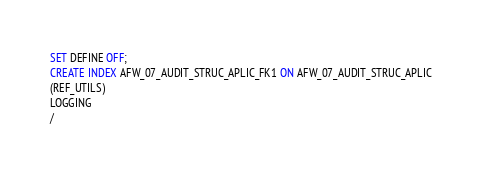Convert code to text. <code><loc_0><loc_0><loc_500><loc_500><_SQL_>SET DEFINE OFF;
CREATE INDEX AFW_07_AUDIT_STRUC_APLIC_FK1 ON AFW_07_AUDIT_STRUC_APLIC
(REF_UTILS)
LOGGING
/
</code> 